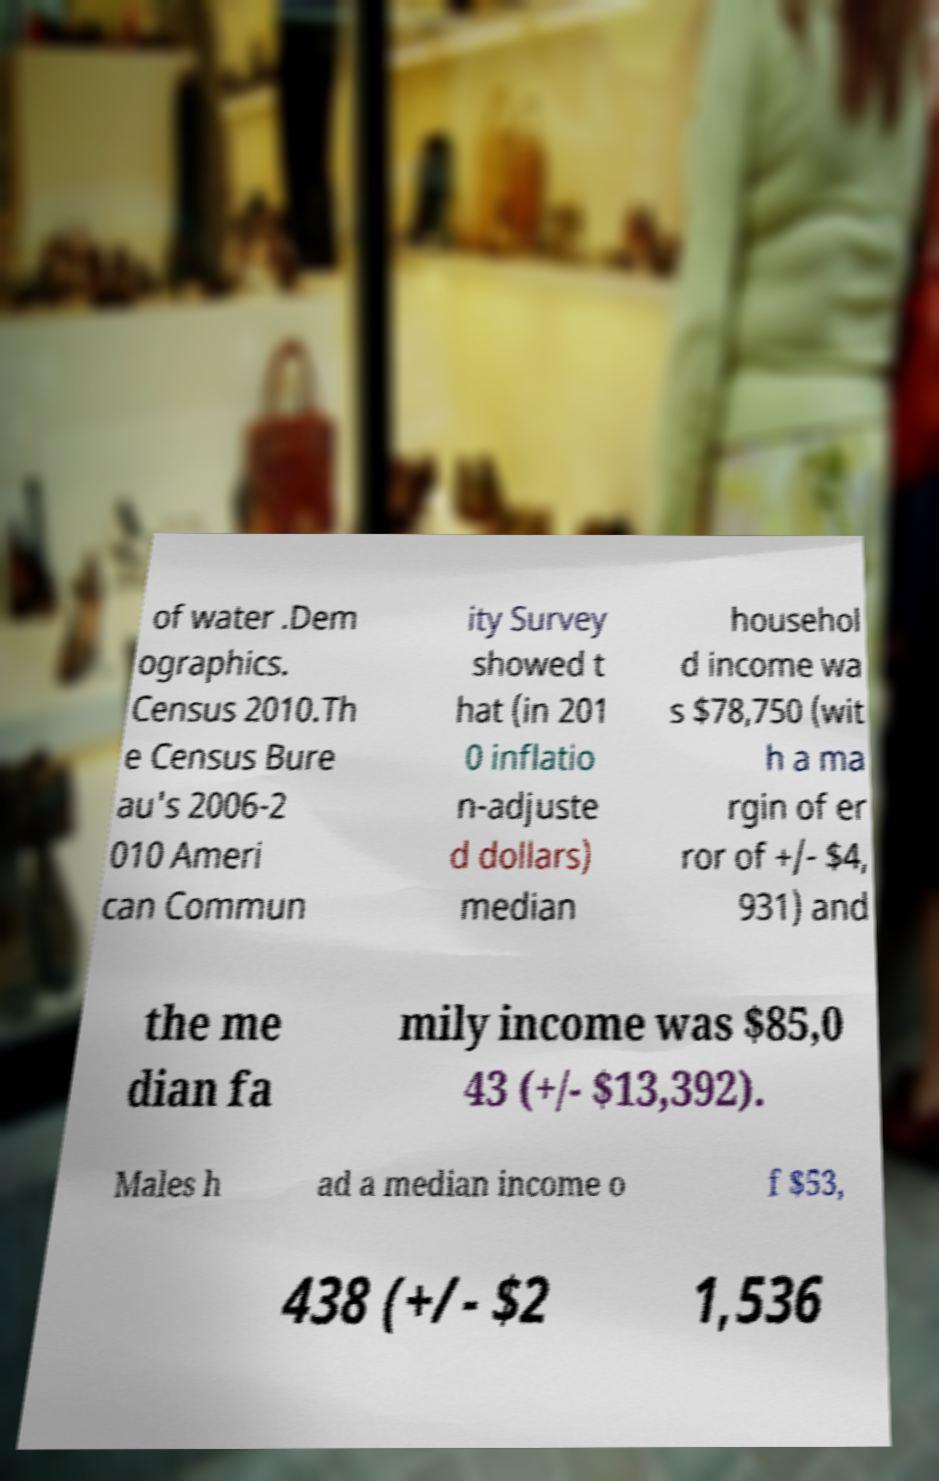Please identify and transcribe the text found in this image. of water .Dem ographics. Census 2010.Th e Census Bure au's 2006-2 010 Ameri can Commun ity Survey showed t hat (in 201 0 inflatio n-adjuste d dollars) median househol d income wa s $78,750 (wit h a ma rgin of er ror of +/- $4, 931) and the me dian fa mily income was $85,0 43 (+/- $13,392). Males h ad a median income o f $53, 438 (+/- $2 1,536 